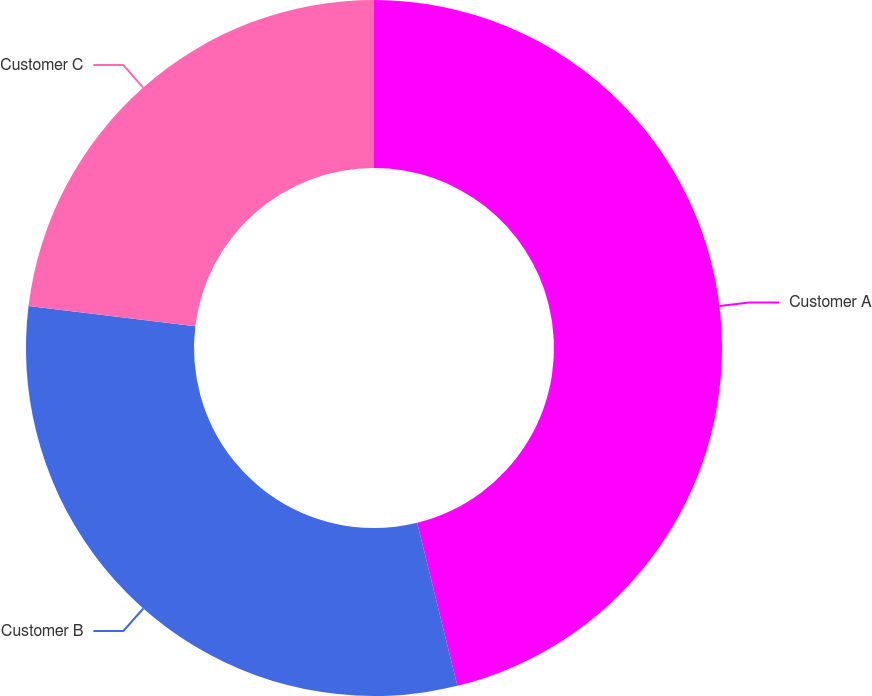Convert chart. <chart><loc_0><loc_0><loc_500><loc_500><pie_chart><fcel>Customer A<fcel>Customer B<fcel>Customer C<nl><fcel>46.15%<fcel>30.77%<fcel>23.08%<nl></chart> 